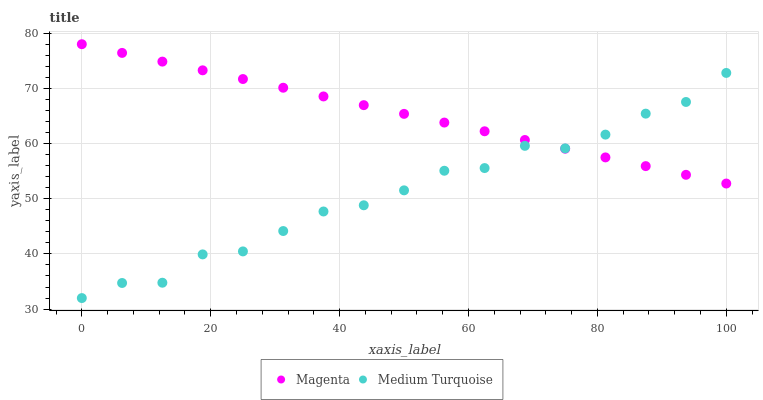Does Medium Turquoise have the minimum area under the curve?
Answer yes or no. Yes. Does Magenta have the maximum area under the curve?
Answer yes or no. Yes. Does Medium Turquoise have the maximum area under the curve?
Answer yes or no. No. Is Magenta the smoothest?
Answer yes or no. Yes. Is Medium Turquoise the roughest?
Answer yes or no. Yes. Is Medium Turquoise the smoothest?
Answer yes or no. No. Does Medium Turquoise have the lowest value?
Answer yes or no. Yes. Does Magenta have the highest value?
Answer yes or no. Yes. Does Medium Turquoise have the highest value?
Answer yes or no. No. Does Magenta intersect Medium Turquoise?
Answer yes or no. Yes. Is Magenta less than Medium Turquoise?
Answer yes or no. No. Is Magenta greater than Medium Turquoise?
Answer yes or no. No. 